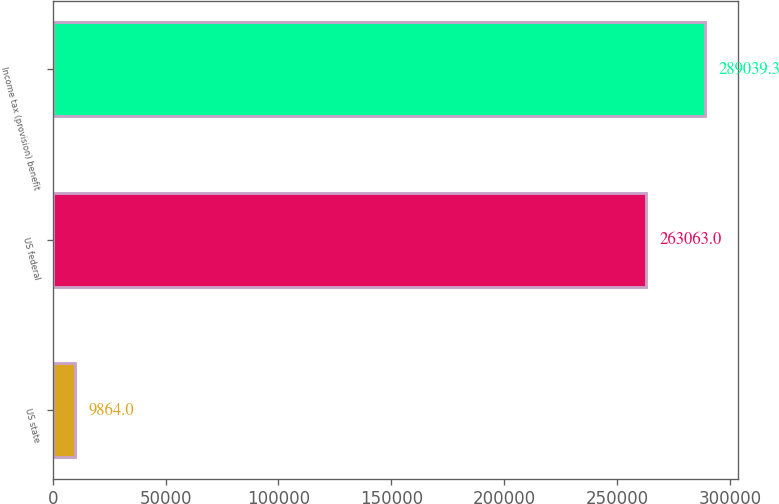<chart> <loc_0><loc_0><loc_500><loc_500><bar_chart><fcel>US state<fcel>US federal<fcel>Income tax (provision) benefit<nl><fcel>9864<fcel>263063<fcel>289039<nl></chart> 